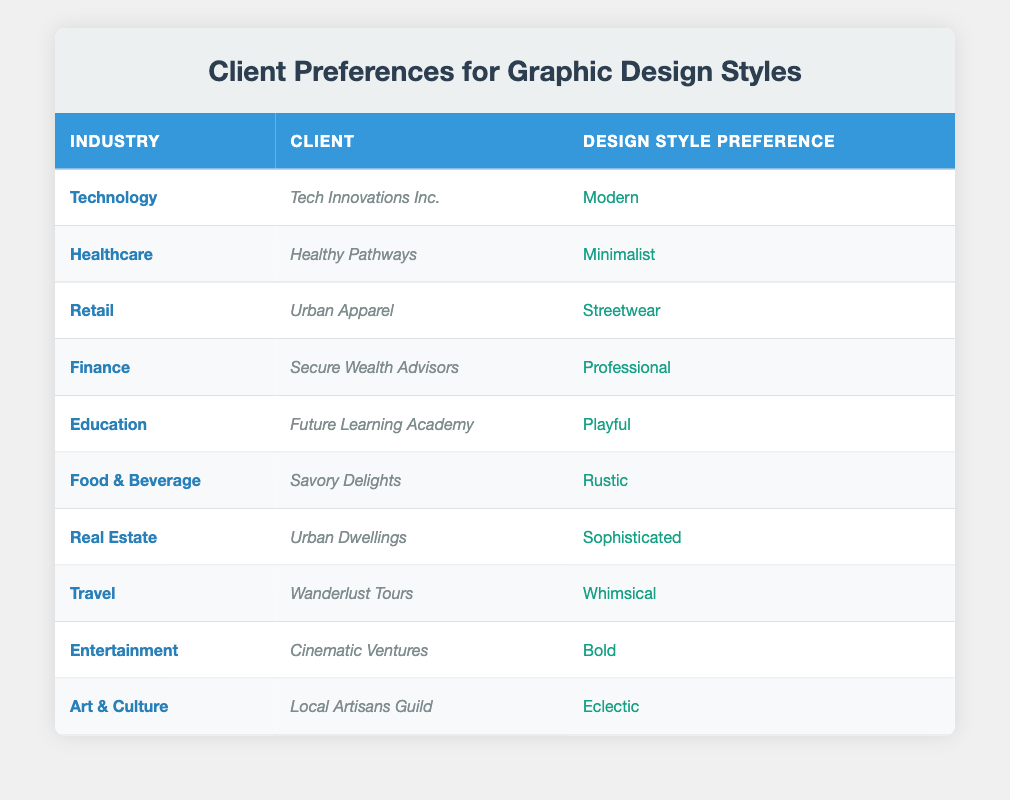What design style preference does Healthy Pathways have? Healthy Pathways is located in the Healthcare industry, and its design style preference is listed in the table. By searching for 'Healthcare' in the 'Industry' column, we can find that the associated 'Design Style Preference' is 'Minimalist.'
Answer: Minimalist Which industry has a design style preference of Whimsical? By scanning through the table, we find the 'Travel' industry is associated with the 'Wanderlust Tours' client, which has the design style preference listed as 'Whimsical.'
Answer: Travel How many unique design style preferences are represented in the table? The table lists 10 clients, each with a distinct design style preference. Examining the design styles, we can count: Modern, Minimalist, Streetwear, Professional, Playful, Rustic, Sophisticated, Whimsical, Bold, and Eclectic, giving us a total of 10 unique styles.
Answer: 10 Does Urban Dwellings prefer a Bold design style? The table states that Urban Dwellings is a client in the Real Estate industry with a design style preference for 'Sophisticated'. Therefore, the answer to whether their preference is 'Bold' is no.
Answer: No Which industry has the most creative design style preference on the list? In the table, 'Art & Culture' with client 'Local Artisans Guild' has an 'Eclectic' design style, which is often considered the most creative among the listed styles. By evaluating the list, it stands out as unique and imaginative compared to other preferences.
Answer: Art & Culture What is the difference in the number of clients that prefer Modern versus Professional design styles? The table lists 1 client, 'Tech Innovations Inc.', for the 'Modern' style and 1 client, 'Secure Wealth Advisors', for the 'Professional' style. We can calculate the difference: 1 (Modern) - 1 (Professional) = 0. Thus, there is no difference in the number of clients preferring these styles.
Answer: 0 If we were to categorize the design style preferences into two groups: minimalist and non-minimalist, how many clients fall into each category? In the table, 'Healthy Pathways' is the only client listed with a 'Minimalist' preference. The remaining clients (those listed with other styles) include 9 clients (as they all have different styles). Thus, we categorize: 1 client (Minimalist) and 9 clients (Non-minimalist).
Answer: Minimalist: 1, Non-minimalist: 9 Are there any clients in the Finance industry that prefer an Eclectic design style? By examining the table, the associated client for the Finance industry is 'Secure Wealth Advisors,' with a design style preference for 'Professional.' This means there are no clients in the Finance industry that prefer an 'Eclectic' style.
Answer: No 